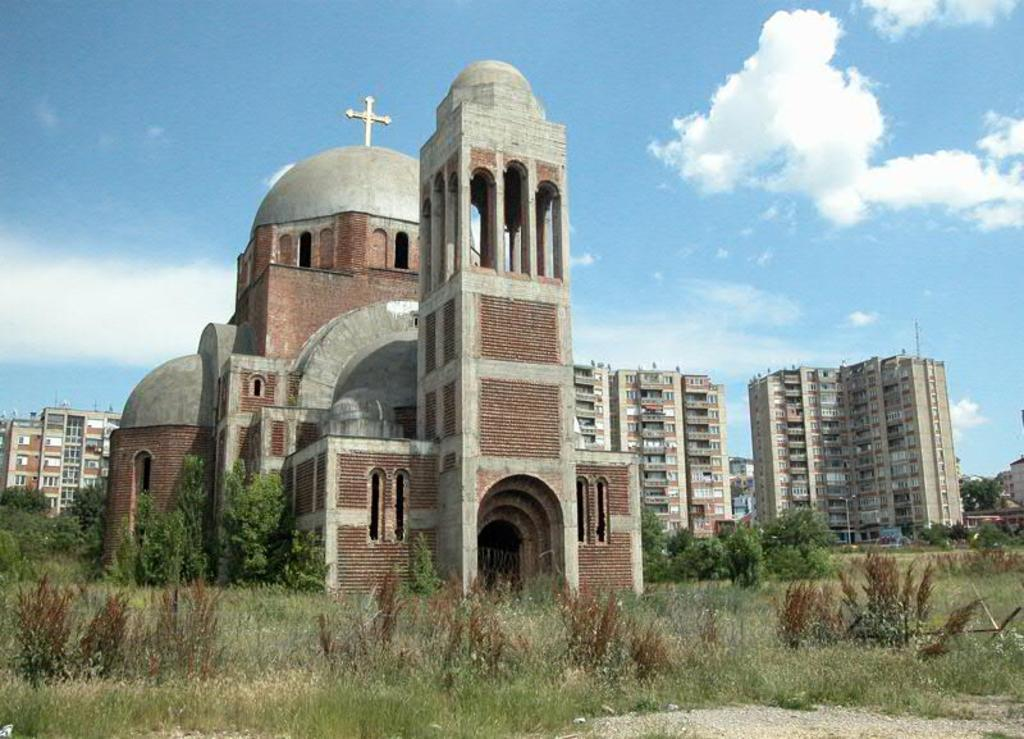What type of building is the main subject of the image? There is a church in the image. Where is the church located in relation to the other elements in the image? The church is in the front of the image. What can be seen behind the church? There are buildings behind the church. Can you describe the landscape surrounding the buildings? The buildings are on a grassland, and there are trees on either side of the land. What is visible in the sky in the image? The sky is visible in the image, and clouds are present. How many parcels can be seen on the grassland in the image? There are no parcels present in the image; it features a church, buildings, trees, and a sky with clouds. 